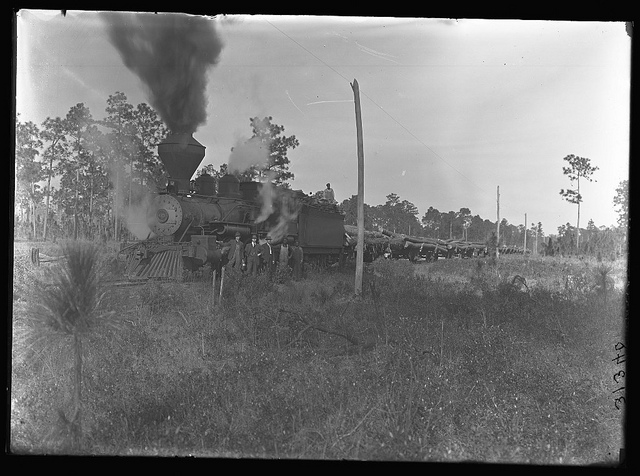<image>What year was this photo taken? It is unknown what year the photo was taken. The guesses range from 1850 to 1955. What year was this photo taken? I don't know what year this photo was taken. It can be any year between 1890 and 1955. 